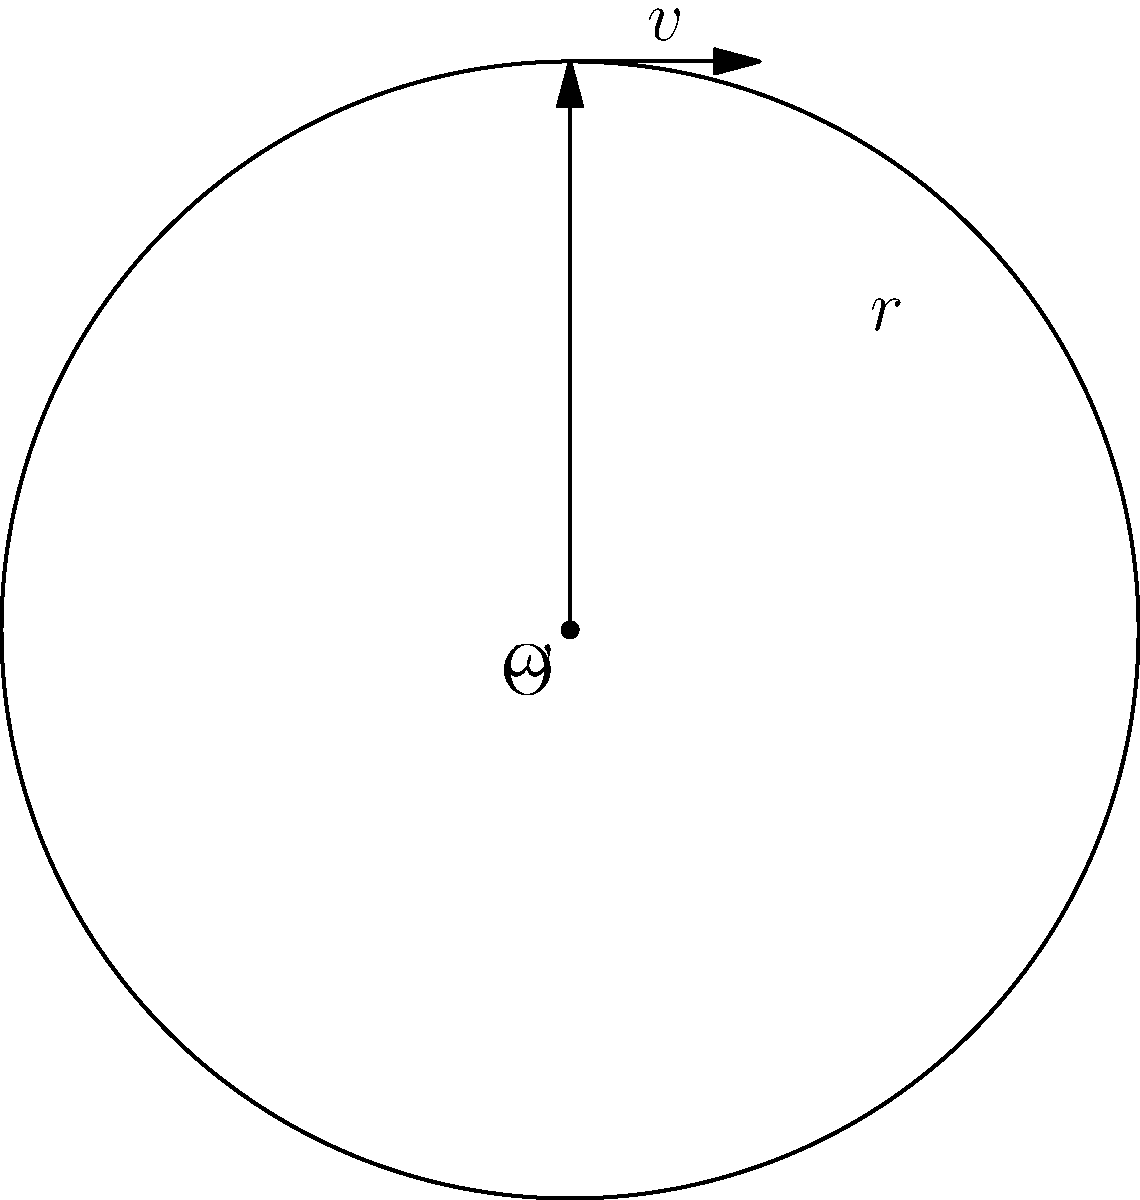A pitcher throws a curveball with a radius of rotation of 7 cm. If the ball completes one full rotation in 0.5 seconds, what is the spin rate of the curveball in revolutions per minute (RPM)? To solve this problem, we'll use the equation for angular velocity and convert it to RPM. Let's break it down step-by-step:

1) First, we need to calculate the angular velocity ($\omega$) in radians per second.
   One full rotation = $2\pi$ radians
   Time for one rotation = 0.5 seconds
   
   $\omega = \frac{2\pi}{0.5} = 4\pi$ rad/s

2) Now, we need to convert this to revolutions per minute (RPM).
   We know that $2\pi$ radians = 1 revolution
   So, $4\pi$ rad/s = 2 rev/s

3) To convert from revolutions per second to revolutions per minute:
   $2$ rev/s * $60$ s/min = $120$ RPM

Therefore, the spin rate of the curveball is 120 RPM.
Answer: 120 RPM 